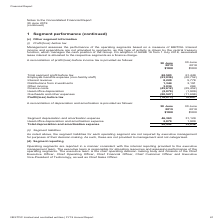According to Nextdc's financial document, How do NextDC Management assess performance of the operating segments? based on a measure of EBITDA.. The document states: "assesses the performance of the operating segments based on a measure of EBITDA. Interest income and expenditure are not allocated to segments, as thi..." Also, What was the change in accounting for leases introduced by new adopted accounting standard AASB 16? associated lease interest is allocated to the respective segments as a finance charge.. The document states: "he Group. On adoption of AASB 16 from 1 July 2018, associated lease interest is allocated to the respective segments as a finance charge...." Also, What was the total segment profit before tax in FY18? According to the financial document, 61,449 (in thousands). The relevant text states: "Total segment profit before tax 62,583 61,449 Employee benefits expense (non-facility staff) (23,036) (20,752) Interest revenue 8,220 5,778 Distr..." Also, can you calculate: What was the total expenses in FY2019? Based on the calculation: 23,036 + 45,612 + 2,079 + 20,527 , the result is 91254 (in thousands). This is based on the information: "costs (45,612) (25,452) Head office depreciation (2,079) (1,909) Overheads and other expenses (20,527) (11,698) Profit/(loss) before tax (16,073) 10,891 ion (2,079) (1,909) Overheads and other expense..." The key data points involved are: 2,079, 20,527, 23,036. Additionally, Which year(s) incurred a loss before tax? According to the financial document, 2019. The relevant text states: "otes to the Consolidated Financial Report 30 June 2019 (continued)..." Also, can you calculate: What was the percentage change in finance costs between 2018 and 2019? To answer this question, I need to perform calculations using the financial data. The calculation is: (45,612 - 25,452) / 25,452 , which equals 79.21 (percentage). This is based on the information: "91 Other income 3,034 284 Finance costs (45,612) (25,452) Head office depreciation (2,079) (1,909) Overheads and other expenses (20,527) (11,698) Profit/(lo 1,344 3,191 Other income 3,034 284 Finance ..." The key data points involved are: 25,452, 45,612. 